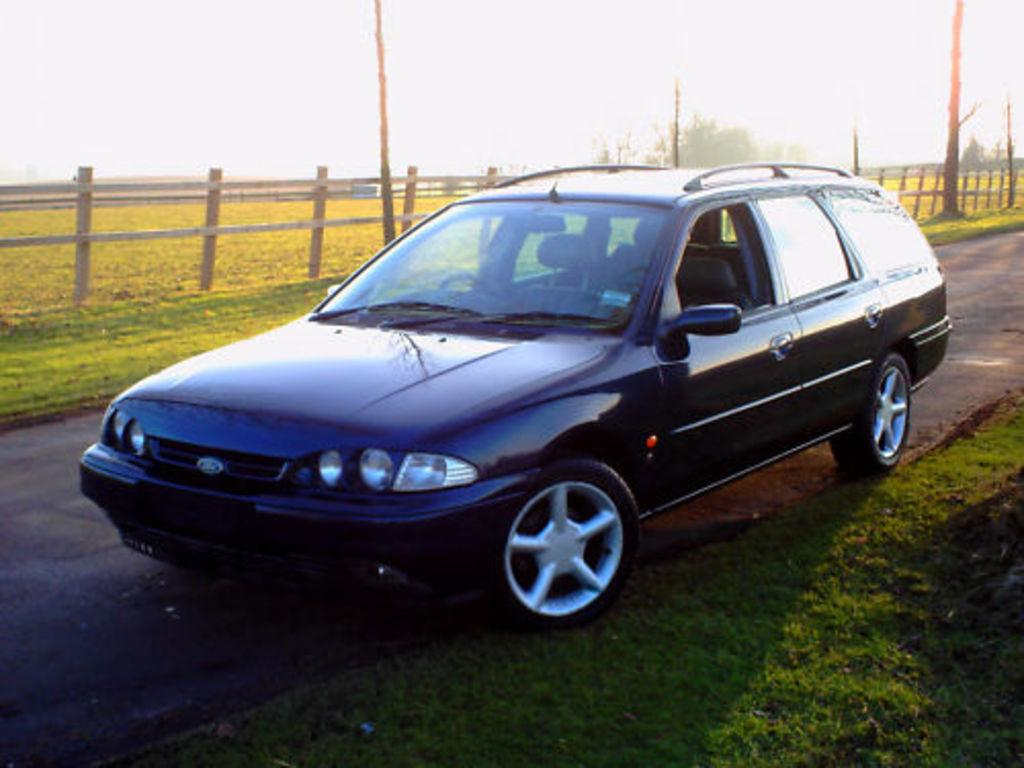What color is the car in the image? The car in the image is black. Where is the car located in the image? The car is parked on the road. What type of vegetation can be seen in the image? There are trees and grass visible in the image. What type of barrier can be seen in the image? There is a wooden fence in the image. What type of structures can be seen in the image? There are poles in the image. What part of the natural environment is visible in the image? The sky is visible in the image. What type of blood is visible in the image? There is no blood visible in the image. What type of eggnog can be seen in the image? There is no eggnog present in the image. 